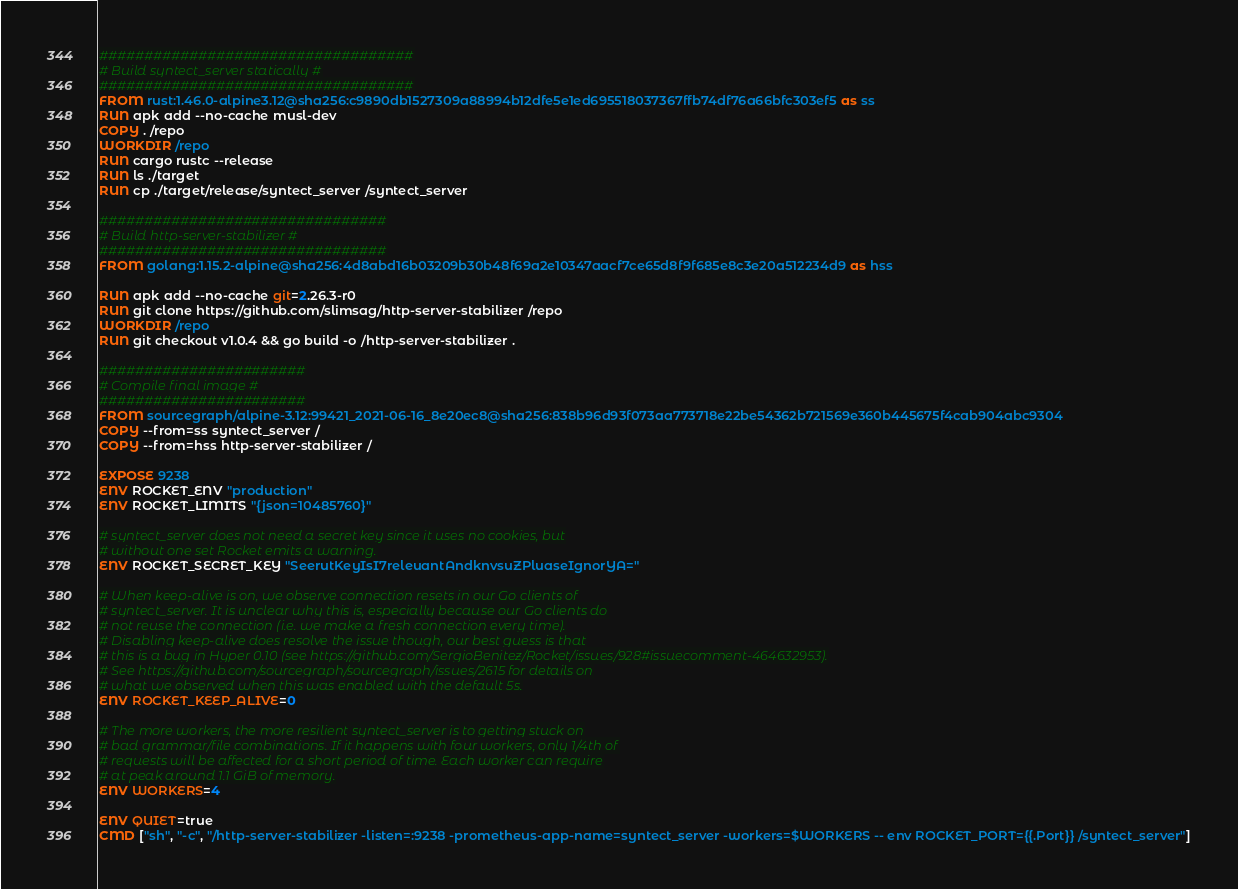<code> <loc_0><loc_0><loc_500><loc_500><_Dockerfile_>###################################
# Build syntect_server statically #
###################################
FROM rust:1.46.0-alpine3.12@sha256:c9890db1527309a88994b12dfe5e1ed695518037367ffb74df76a66bfc303ef5 as ss
RUN apk add --no-cache musl-dev
COPY . /repo
WORKDIR /repo
RUN cargo rustc --release
RUN ls ./target
RUN cp ./target/release/syntect_server /syntect_server

################################
# Build http-server-stabilizer #
################################
FROM golang:1.15.2-alpine@sha256:4d8abd16b03209b30b48f69a2e10347aacf7ce65d8f9f685e8c3e20a512234d9 as hss

RUN apk add --no-cache git=2.26.3-r0
RUN git clone https://github.com/slimsag/http-server-stabilizer /repo
WORKDIR /repo
RUN git checkout v1.0.4 && go build -o /http-server-stabilizer .

#######################
# Compile final image #
#######################
FROM sourcegraph/alpine-3.12:99421_2021-06-16_8e20ec8@sha256:838b96d93f073aa773718e22be54362b721569e360b445675f4cab904abc9304
COPY --from=ss syntect_server /
COPY --from=hss http-server-stabilizer /

EXPOSE 9238
ENV ROCKET_ENV "production"
ENV ROCKET_LIMITS "{json=10485760}"

# syntect_server does not need a secret key since it uses no cookies, but
# without one set Rocket emits a warning.
ENV ROCKET_SECRET_KEY "SeerutKeyIsI7releuantAndknvsuZPluaseIgnorYA="

# When keep-alive is on, we observe connection resets in our Go clients of
# syntect_server. It is unclear why this is, especially because our Go clients do
# not reuse the connection (i.e. we make a fresh connection every time).
# Disabling keep-alive does resolve the issue though, our best guess is that
# this is a bug in Hyper 0.10 (see https://github.com/SergioBenitez/Rocket/issues/928#issuecomment-464632953).
# See https://github.com/sourcegraph/sourcegraph/issues/2615 for details on
# what we observed when this was enabled with the default 5s.
ENV ROCKET_KEEP_ALIVE=0

# The more workers, the more resilient syntect_server is to getting stuck on
# bad grammar/file combinations. If it happens with four workers, only 1/4th of
# requests will be affected for a short period of time. Each worker can require
# at peak around 1.1 GiB of memory.
ENV WORKERS=4

ENV QUIET=true
CMD ["sh", "-c", "/http-server-stabilizer -listen=:9238 -prometheus-app-name=syntect_server -workers=$WORKERS -- env ROCKET_PORT={{.Port}} /syntect_server"]
</code> 